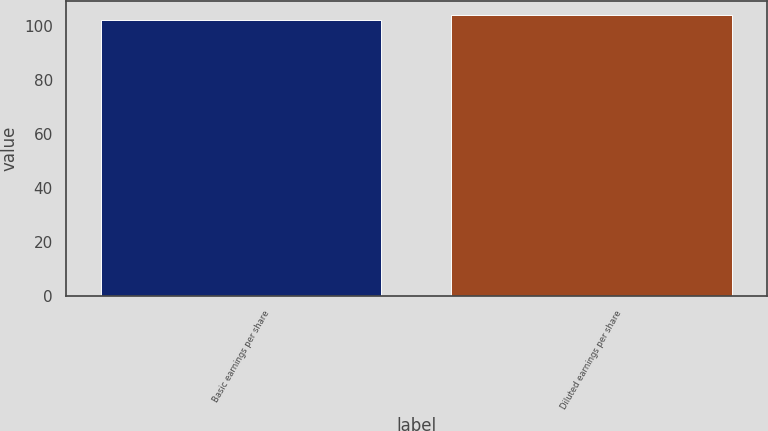<chart> <loc_0><loc_0><loc_500><loc_500><bar_chart><fcel>Basic earnings per share<fcel>Diluted earnings per share<nl><fcel>102.5<fcel>104.3<nl></chart> 